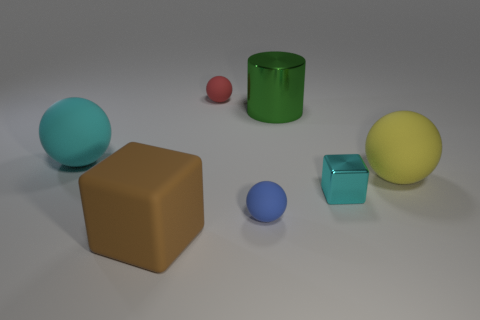Is the number of brown matte things that are behind the tiny cyan thing less than the number of large cylinders behind the big cyan ball?
Offer a terse response. Yes. The small matte ball that is in front of the large cyan thing is what color?
Your response must be concise. Blue. There is a shiny thing that is in front of the large matte ball on the right side of the tiny red rubber object; how many small cyan cubes are left of it?
Offer a terse response. 0. What size is the shiny block?
Your answer should be very brief. Small. There is a blue sphere that is the same size as the metal block; what material is it?
Offer a very short reply. Rubber. There is a tiny cube; what number of small cyan shiny cubes are in front of it?
Your answer should be very brief. 0. Is the material of the ball that is behind the big cyan matte object the same as the cube to the right of the big brown matte cube?
Ensure brevity in your answer.  No. There is a large rubber object that is in front of the metal object in front of the rubber sphere on the right side of the cyan metallic block; what shape is it?
Your answer should be compact. Cube. What shape is the small cyan metallic thing?
Your answer should be very brief. Cube. There is a yellow matte object that is the same size as the green metal cylinder; what shape is it?
Your answer should be very brief. Sphere. 